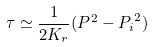Convert formula to latex. <formula><loc_0><loc_0><loc_500><loc_500>\tau \simeq \frac { 1 } { 2 K _ { r } } ( P ^ { 2 } - { P _ { i } } ^ { 2 } )</formula> 